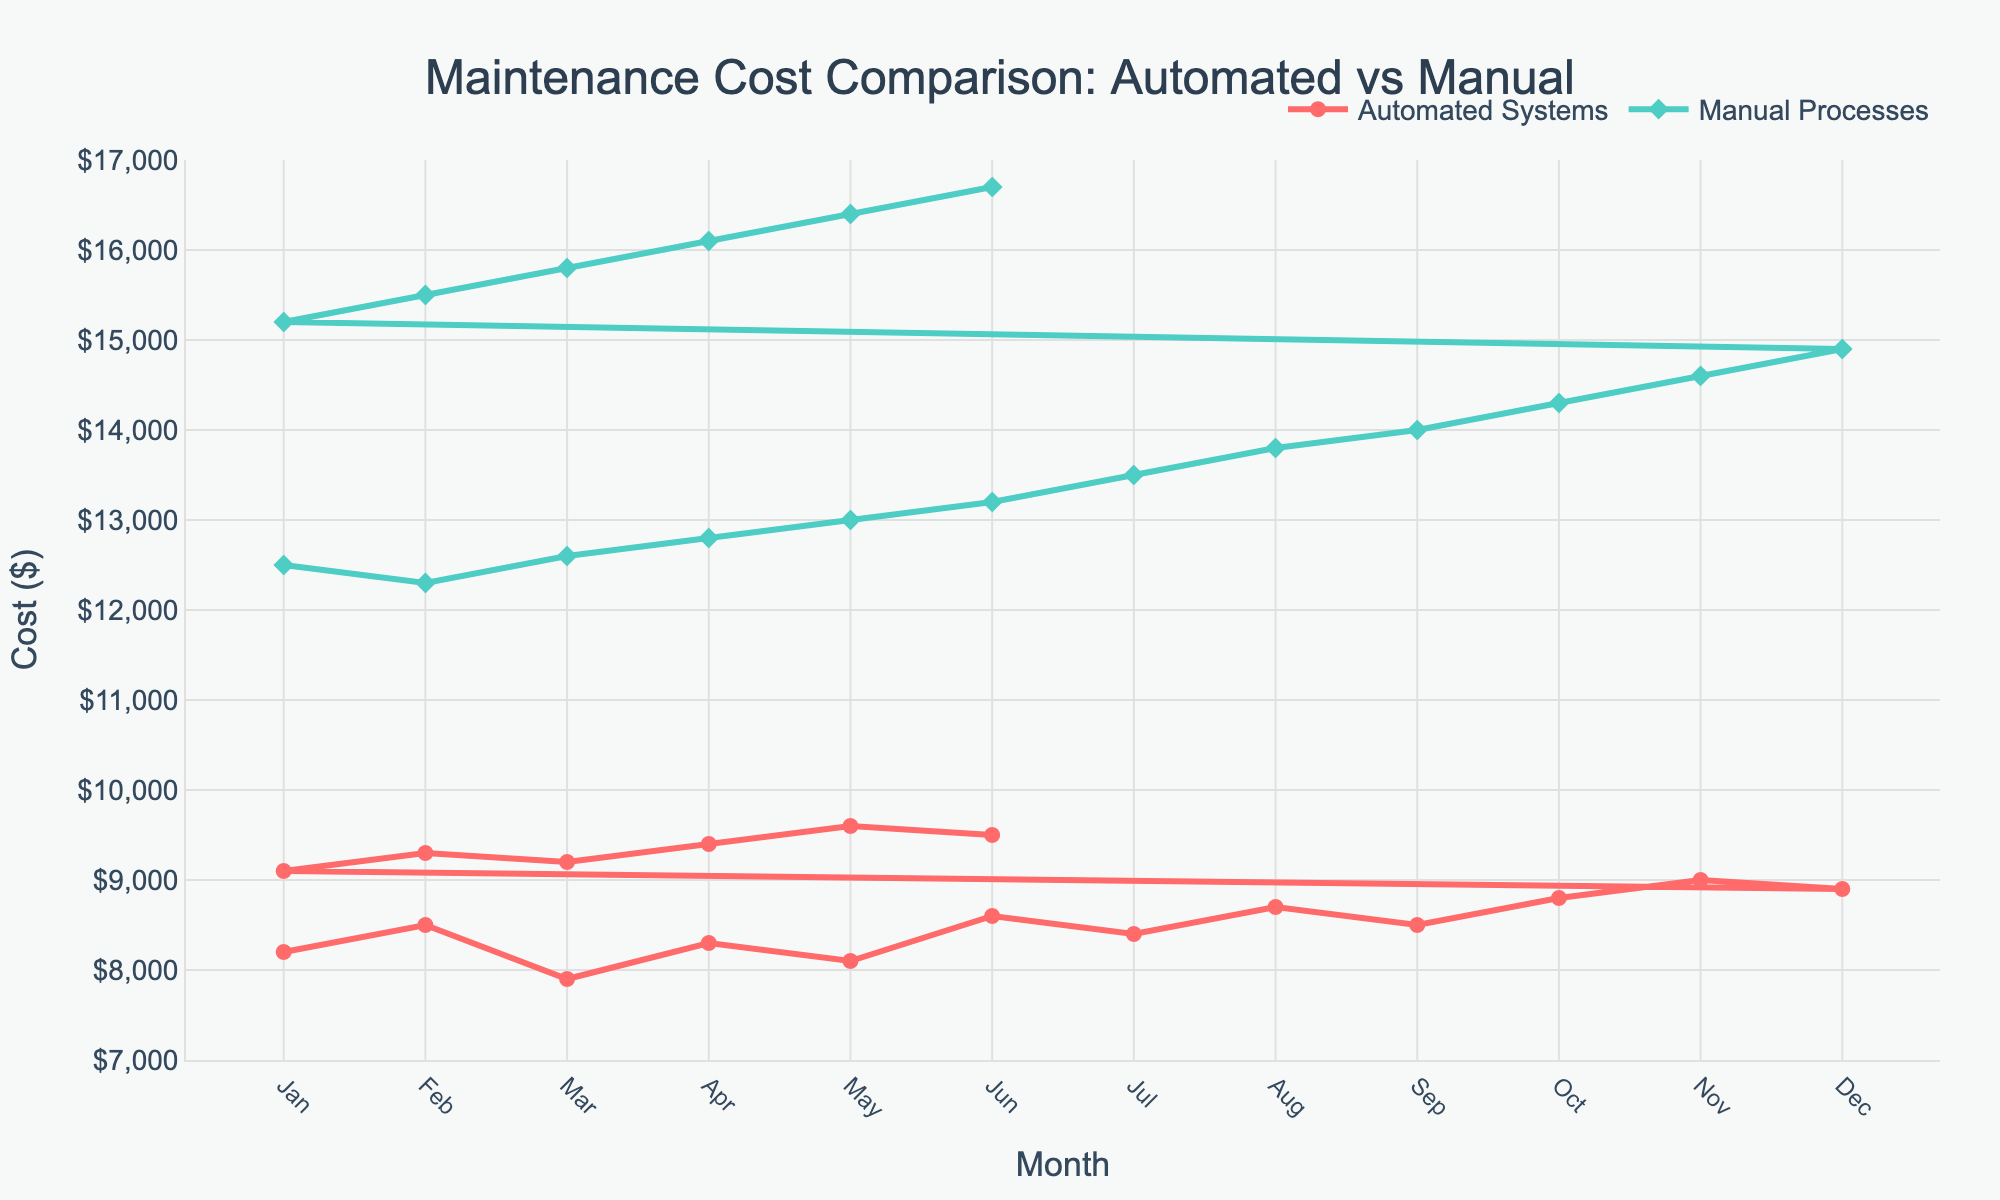What is the overall trend of maintenance costs for Automated Systems from Jan to Jun? The maintenance costs for Automated Systems generally show an increasing trend. Starting from $8200 in Jan, the costs fluctuate but generally rise to $8600 in Jun.
Answer: Increasing In which month is the maintenance cost gap between Automated Systems and Manual Processes the smallest? In March, the costs for Automated Systems are $7900, and for Manual Processes, it is $12600. The gap between them is $4700, which is the smallest gap among all months.
Answer: March On average, are the maintenance costs for Automated Systems or Manual Processes higher? Summing up the Automated Systems costs: $8200 + $8500 + $7900 + $8300 + $8100 + $8600 + $8400 + $8700 + $8500 + $8800 + $9000 + $8900 + $9100 + $9300 + $9200 + $9400 + $9600 + $9500 = $155500. Dividing this by 18 months averages to approximately $8639. Summing up the Manual Processes costs: $12500 + $12300 + $12600 + $12800 + $13000 + $13200 + $13500 + $13800 + $14000 + $14300 + $14600 + $14900 + $15200 + $15500 + $15800 + $16100 + $16400 + $16700 = $263900. Dividing this by 18 months averages to approximately $14661. Thus, Manual Processes have higher costs on average.
Answer: Manual Processes Which month saw the highest maintenance cost for Automated Systems, and what was the value? November saw the highest maintenance cost for Automated Systems with a value of $9000.
Answer: November, $9000 How did the maintenance costs for Manual Processes change from April to May? The costs for Manual Processes increased from $12800 in April to $13000 in May. This is a change of $200.
Answer: Increased, $200 What is the range of maintenance costs for Manual Processes from Jan to Dec? The lowest maintenance cost for Manual Processes in this period is $12300 (Feb), and the highest is $14900 (Dec). Thus, the range is $14900 - $12300 = $2600.
Answer: $2600 Compare the maintenance costs for both Automated Systems and Manual Processes in February. Which is higher and by how much? In February, the maintenance cost for Automated Systems is $8500 and for Manual Processes is $12300. The difference is $12300 - $8500 = $3800, with Manual Processes being higher.
Answer: Manual Processes, $3800 By how much do the Automated Systems' maintenance costs in July exceed those in January? In July, the maintenance costs are $8400, and in January, they are $8200. The difference is $8400 - $8200 = $200.
Answer: $200 Are there any months where the maintenance costs for Automated Systems decreased compared to the previous month? Yes, in March, the costs decreased to $7900 from $8500 in February, and also in May, they dropped to $8100 from $8300 in April.
Answer: March and May Calculate the average maintenance cost for Automated Systems from Jan to Dec. Summing up the costs for Automated Systems: $8200 + $8500 + $7900 + $8300 + $8100 + $8600 + $8400 + $8700 + $8500 + $8800 + $9000 + $8900 = $103900. Dividing this by 12 months averages to approximately $8658.33.
Answer: $8658.33 